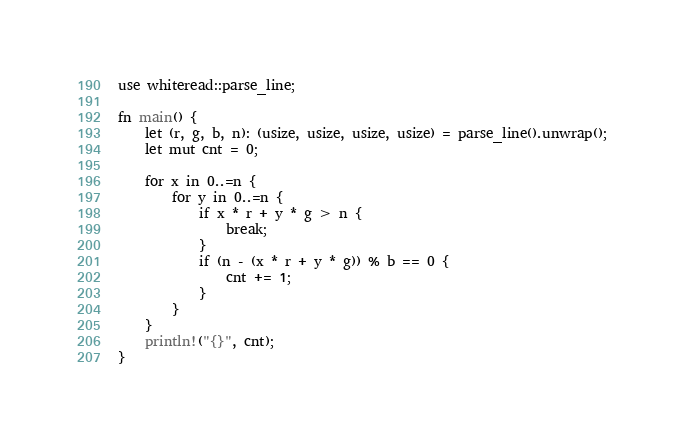<code> <loc_0><loc_0><loc_500><loc_500><_Rust_>use whiteread::parse_line;

fn main() {
    let (r, g, b, n): (usize, usize, usize, usize) = parse_line().unwrap();
    let mut cnt = 0;

    for x in 0..=n {
        for y in 0..=n {
            if x * r + y * g > n {
                break;
            }
            if (n - (x * r + y * g)) % b == 0 {
                cnt += 1;
            }
        }
    }
    println!("{}", cnt);
}
</code> 